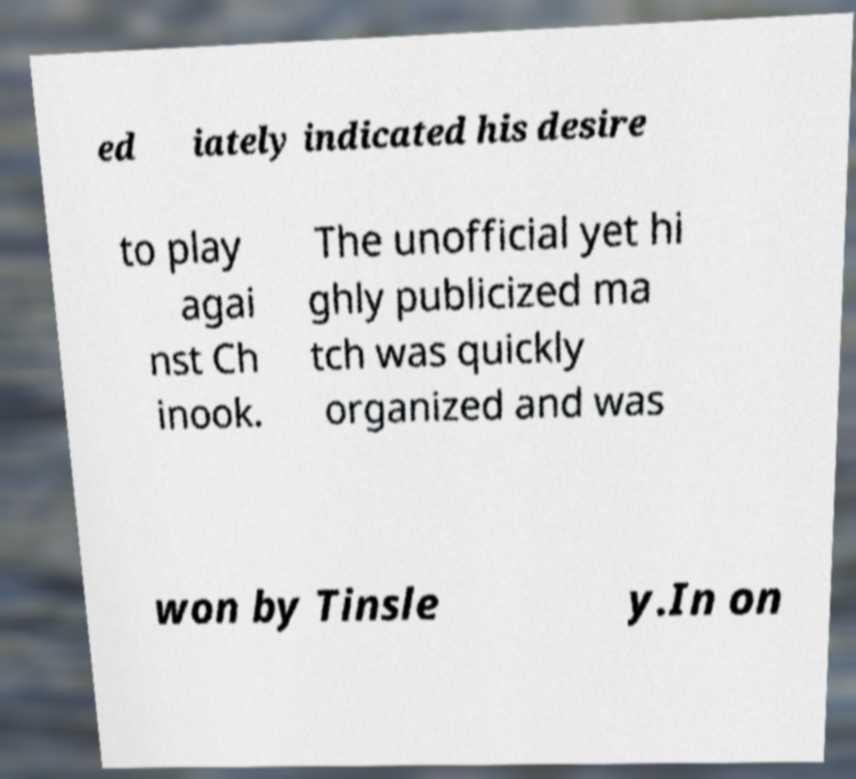Could you extract and type out the text from this image? ed iately indicated his desire to play agai nst Ch inook. The unofficial yet hi ghly publicized ma tch was quickly organized and was won by Tinsle y.In on 